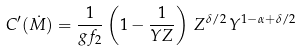Convert formula to latex. <formula><loc_0><loc_0><loc_500><loc_500>C ^ { \prime } ( \dot { M } ) = \frac { 1 } { g f _ { 2 } } \left ( 1 - \frac { 1 } { Y Z } \right ) \, Z ^ { \delta / 2 } \, Y ^ { 1 - \alpha + \delta / 2 }</formula> 